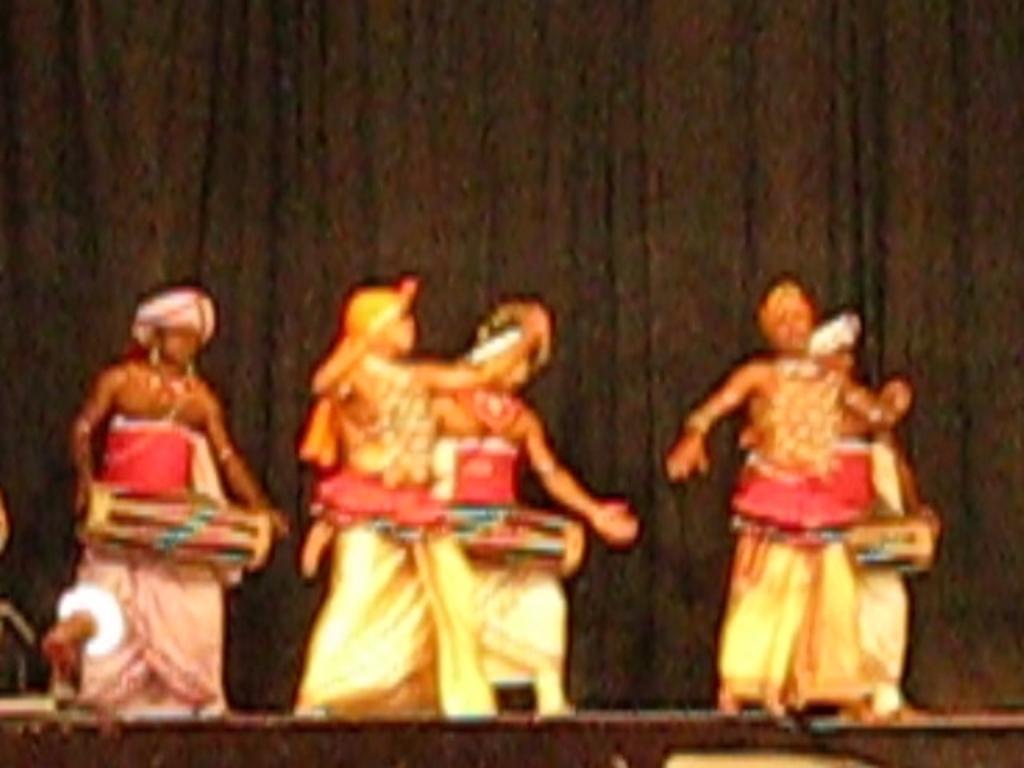How would you summarize this image in a sentence or two? In the picture we can see some people are standing on the stage and playing the musical instruments and behind them we can see a black color curtain. 